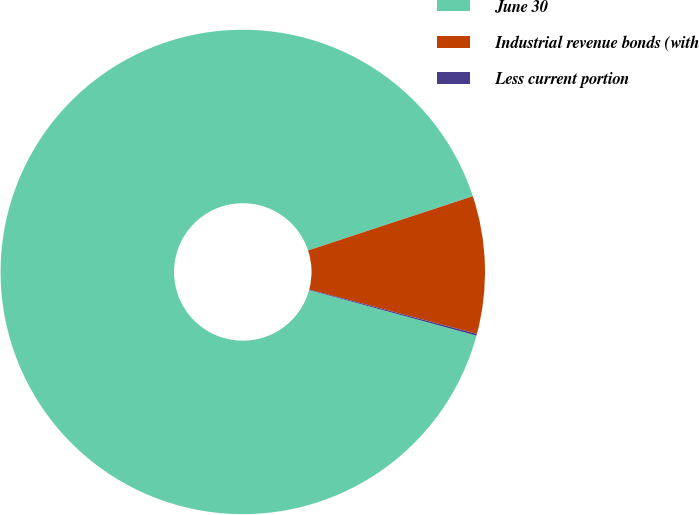Convert chart to OTSL. <chart><loc_0><loc_0><loc_500><loc_500><pie_chart><fcel>June 30<fcel>Industrial revenue bonds (with<fcel>Less current portion<nl><fcel>90.7%<fcel>9.18%<fcel>0.12%<nl></chart> 